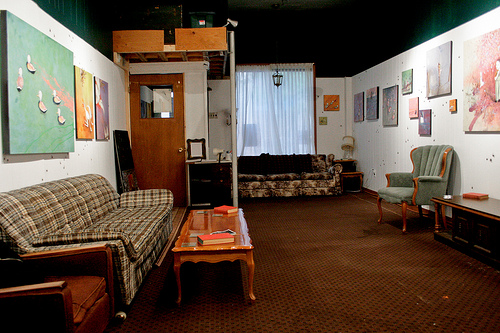<image>
Is there a curtain behind the floor? No. The curtain is not behind the floor. From this viewpoint, the curtain appears to be positioned elsewhere in the scene. Is there a couch in front of the door? Yes. The couch is positioned in front of the door, appearing closer to the camera viewpoint. 